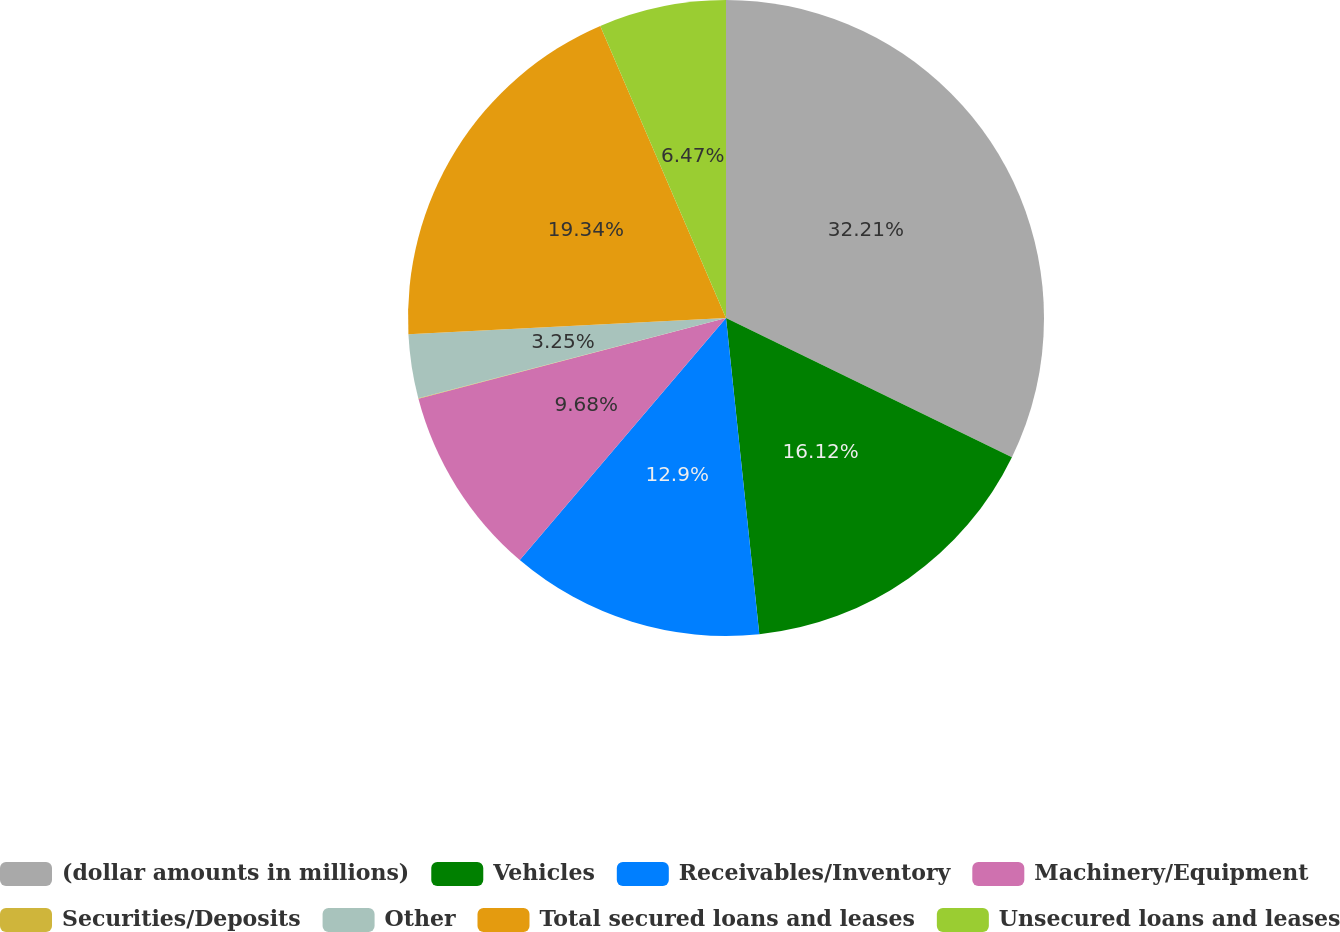<chart> <loc_0><loc_0><loc_500><loc_500><pie_chart><fcel>(dollar amounts in millions)<fcel>Vehicles<fcel>Receivables/Inventory<fcel>Machinery/Equipment<fcel>Securities/Deposits<fcel>Other<fcel>Total secured loans and leases<fcel>Unsecured loans and leases<nl><fcel>32.21%<fcel>16.12%<fcel>12.9%<fcel>9.68%<fcel>0.03%<fcel>3.25%<fcel>19.34%<fcel>6.47%<nl></chart> 